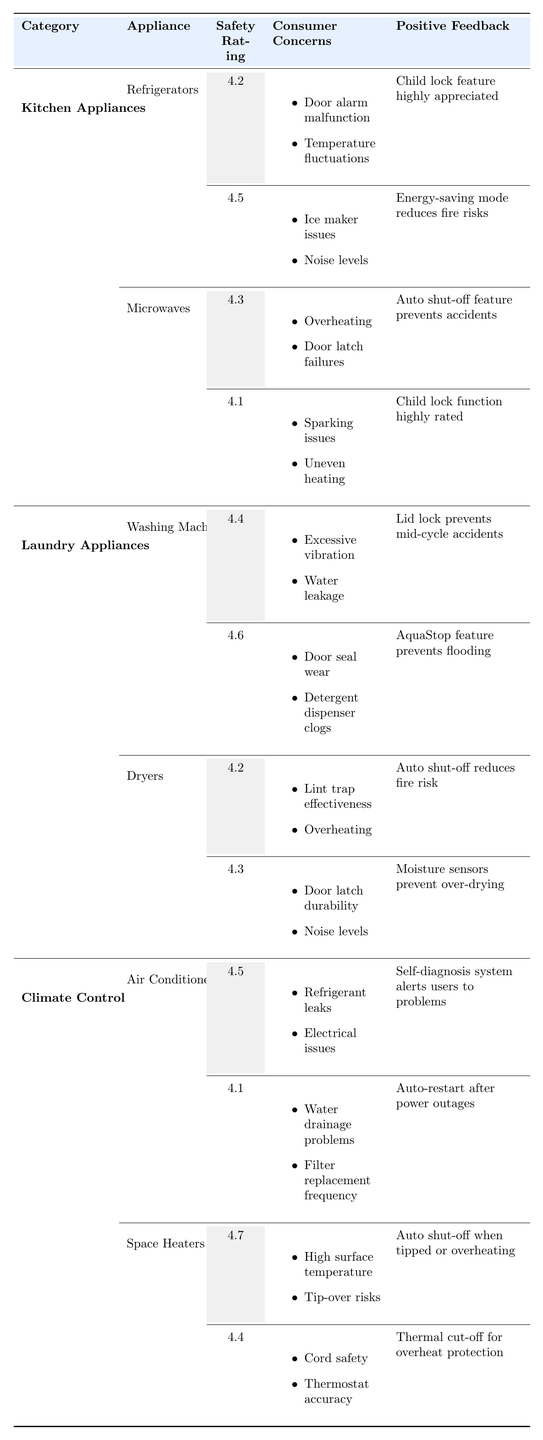What is the safety rating of LG Refrigerators? The safety rating for the LG brand of Refrigerators is present in the table under the appropriate category; it shows 4.5.
Answer: 4.5 Which appliance has the highest safety rating among Kitchen Appliances? Comparing the safety ratings of Refrigerators and Microwaves in the Kitchen Appliances category, LG Refrigerators have a rating of 4.5, while the highest rating for Microwaves is 4.3 (Panasonic). Therefore, LG Refrigerators have the highest safety rating.
Answer: LG Refrigerators Are there any consumer concerns listed for the Bosch Washing Machines? The table indicates that Bosch Washing Machines have two consumer concerns mentioned: "Door seal wear" and "Detergent dispenser clogs." This information is directly obtained from the Consumer Concerns section for Bosch.
Answer: Yes Which appliance in the Laundry Appliances category has the lowest safety rating? Analyzing the safety ratings provided for Washing Machines and Dryers, Maytag Washing Machines have a safety rating of 4.4, while GE Dryers have a rating of 4.2. Thus, GE Dryers have the lowest rating.
Answer: GE Dryers How many different brands are listed for Space Heaters? The table shows two brands under the Space Heaters category: Dyson and DeLonghi. Therefore, the count of brands is simply the number listed.
Answer: 2 Which appliance has a consumer concern related to "tip-over risks"? The table identifies "tip-over risks" as a consumer concern under the Dyson brand of Space Heaters. By looking at the Consumer Concerns for each appliance, we find this specific mention.
Answer: Space Heaters What is the average safety rating of the appliances listed in the Climate Control category? The safety ratings for the Climate Control category appliances are 4.5 (Air Conditioners - Daikin), 4.1 (Air Conditioners - Frigidaire), 4.7 (Space Heaters - Dyson), and 4.4 (Space Heaters - DeLonghi). Sum these ratings: 4.5 + 4.1 + 4.7 + 4.4 = 17.7. Divide by 4 (the number of appliances) to get the average: 17.7 / 4 = 4.425.
Answer: 4.425 Is it true that all Kitchen Appliances have consumer concerns related to heating issues? By examining the Consumer Concerns of both Refrigerators and Microwaves in Kitchen Appliances, we see that Refrigerators mention issues such as "door alarm malfunction" and "temperature fluctuations" rather than heating issues, while Microwaves mention "overheating." Therefore, it is not true that all have heating concerns.
Answer: No Identify the brand with the highest safety rating in the Laundry Appliances category. The safety ratings for the two appliances under Laundry Appliances show Maytag Washing Machines at 4.4 and Bosch at 4.6. Bosch has the higher rating, making it the brand with the highest safety rating in this category.
Answer: Bosch 